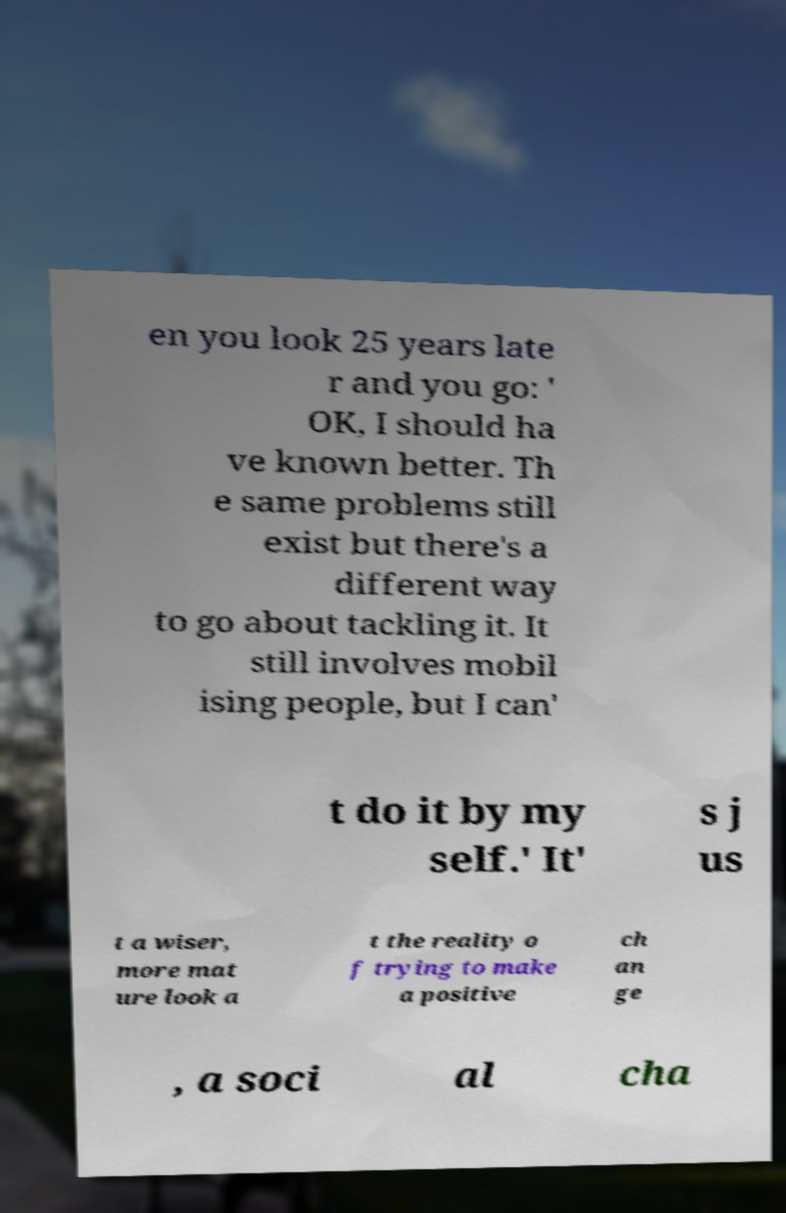For documentation purposes, I need the text within this image transcribed. Could you provide that? en you look 25 years late r and you go: ' OK, I should ha ve known better. Th e same problems still exist but there's a different way to go about tackling it. It still involves mobil ising people, but I can' t do it by my self.' It' s j us t a wiser, more mat ure look a t the reality o f trying to make a positive ch an ge , a soci al cha 